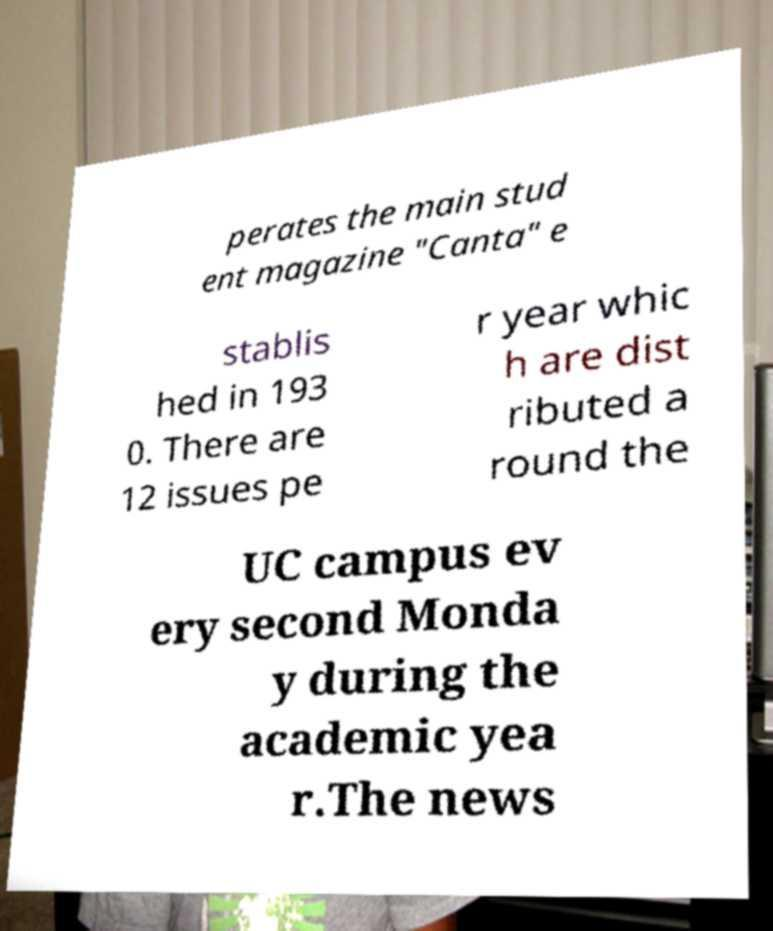Could you assist in decoding the text presented in this image and type it out clearly? perates the main stud ent magazine "Canta" e stablis hed in 193 0. There are 12 issues pe r year whic h are dist ributed a round the UC campus ev ery second Monda y during the academic yea r.The news 